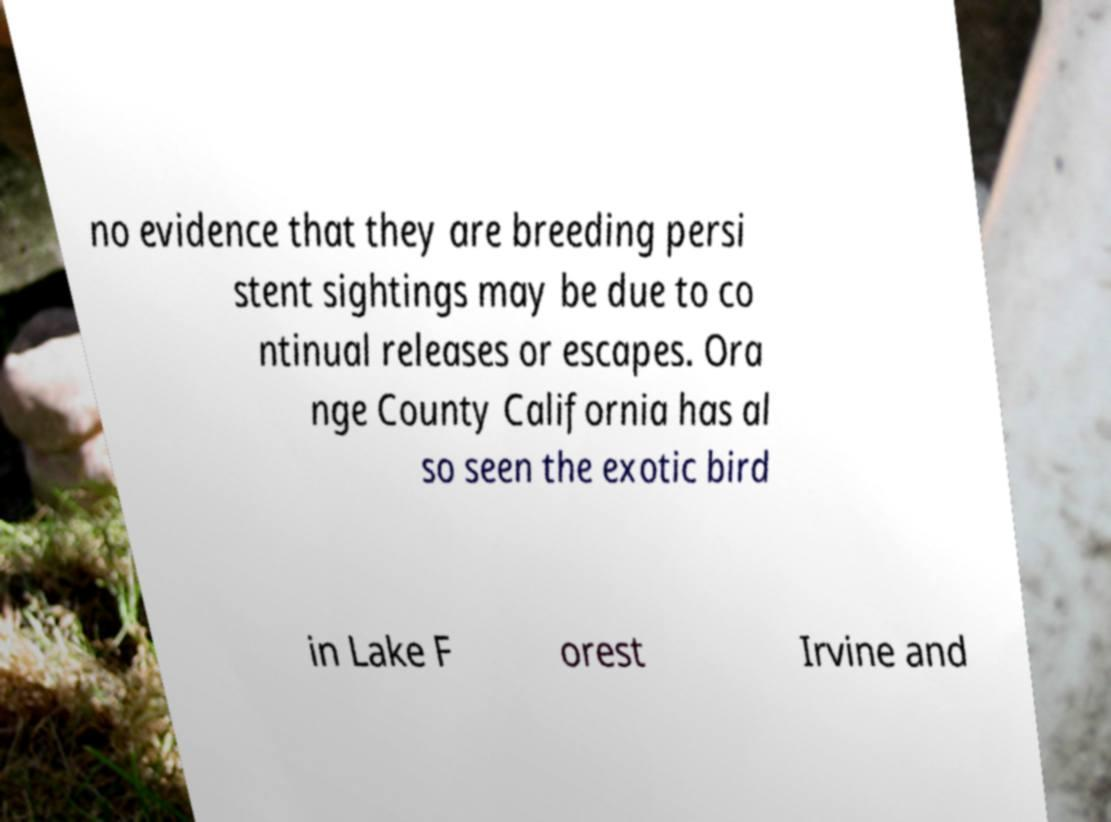I need the written content from this picture converted into text. Can you do that? no evidence that they are breeding persi stent sightings may be due to co ntinual releases or escapes. Ora nge County California has al so seen the exotic bird in Lake F orest Irvine and 